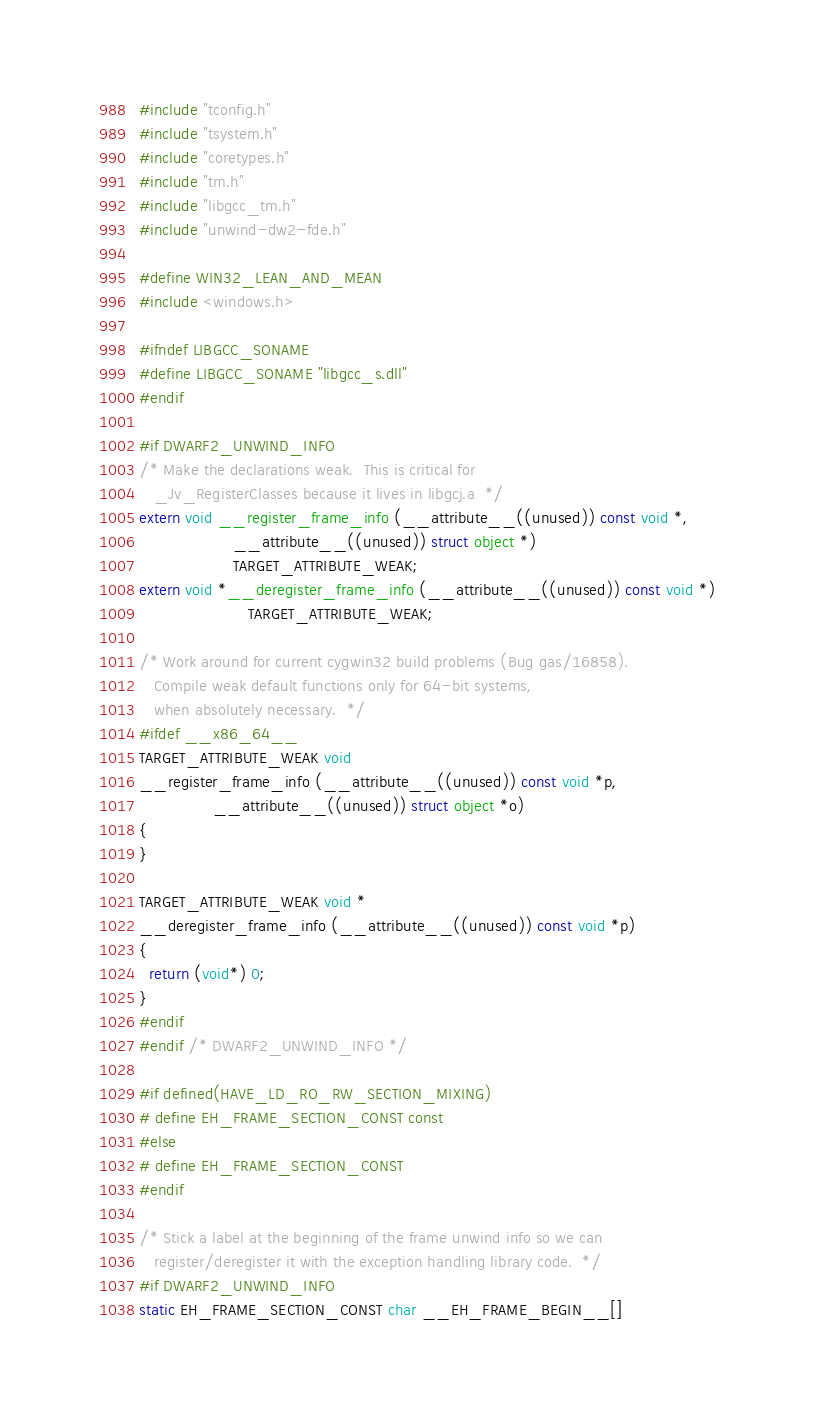<code> <loc_0><loc_0><loc_500><loc_500><_C_>#include "tconfig.h"
#include "tsystem.h"
#include "coretypes.h"
#include "tm.h"
#include "libgcc_tm.h"
#include "unwind-dw2-fde.h"

#define WIN32_LEAN_AND_MEAN
#include <windows.h>

#ifndef LIBGCC_SONAME
#define LIBGCC_SONAME "libgcc_s.dll"
#endif

#if DWARF2_UNWIND_INFO
/* Make the declarations weak.  This is critical for
   _Jv_RegisterClasses because it lives in libgcj.a  */
extern void __register_frame_info (__attribute__((unused)) const void *,
				   __attribute__((unused)) struct object *)
				   TARGET_ATTRIBUTE_WEAK;
extern void *__deregister_frame_info (__attribute__((unused)) const void *)
				      TARGET_ATTRIBUTE_WEAK;

/* Work around for current cygwin32 build problems (Bug gas/16858).
   Compile weak default functions only for 64-bit systems,
   when absolutely necessary.  */
#ifdef __x86_64__
TARGET_ATTRIBUTE_WEAK void
__register_frame_info (__attribute__((unused)) const void *p,
		       __attribute__((unused)) struct object *o)
{
}

TARGET_ATTRIBUTE_WEAK void *
__deregister_frame_info (__attribute__((unused)) const void *p)
{
  return (void*) 0;
}
#endif
#endif /* DWARF2_UNWIND_INFO */

#if defined(HAVE_LD_RO_RW_SECTION_MIXING)
# define EH_FRAME_SECTION_CONST const
#else
# define EH_FRAME_SECTION_CONST
#endif

/* Stick a label at the beginning of the frame unwind info so we can
   register/deregister it with the exception handling library code.  */
#if DWARF2_UNWIND_INFO
static EH_FRAME_SECTION_CONST char __EH_FRAME_BEGIN__[]</code> 